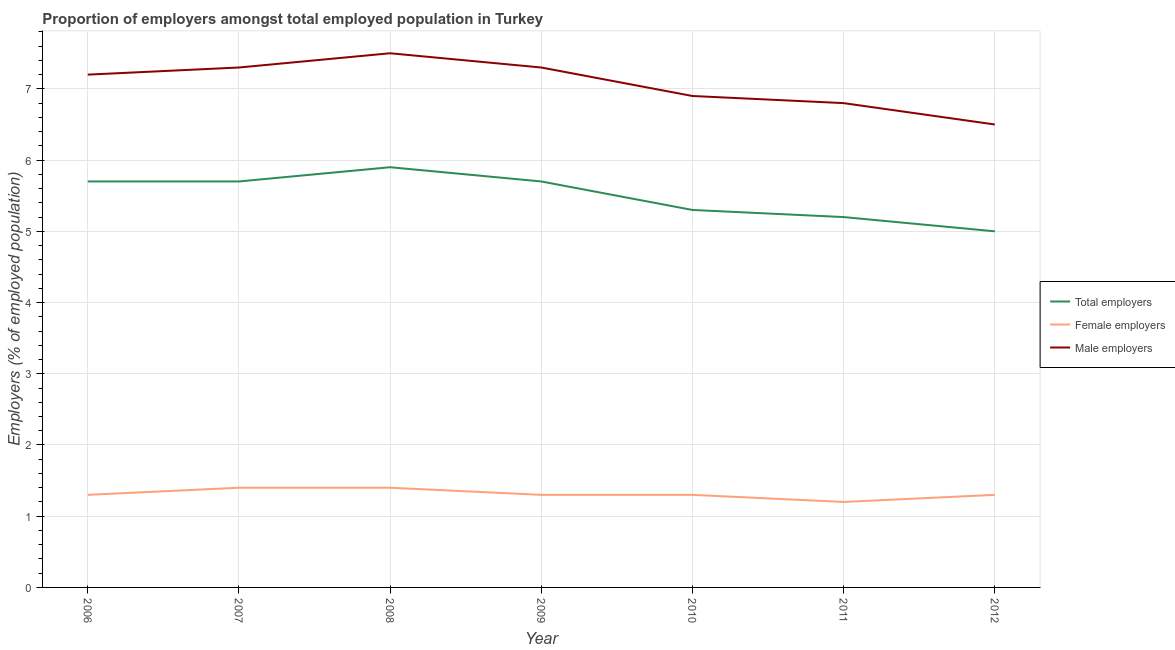What is the percentage of total employers in 2012?
Offer a very short reply. 5. Across all years, what is the maximum percentage of total employers?
Offer a very short reply. 5.9. In which year was the percentage of male employers maximum?
Your answer should be compact. 2008. What is the total percentage of female employers in the graph?
Keep it short and to the point. 9.2. What is the difference between the percentage of total employers in 2008 and that in 2012?
Provide a succinct answer. 0.9. What is the difference between the percentage of male employers in 2007 and the percentage of female employers in 2008?
Provide a succinct answer. 5.9. What is the average percentage of female employers per year?
Provide a short and direct response. 1.31. What is the ratio of the percentage of female employers in 2008 to that in 2010?
Offer a very short reply. 1.08. Is the percentage of female employers in 2007 less than that in 2010?
Offer a terse response. No. Is the difference between the percentage of total employers in 2008 and 2011 greater than the difference between the percentage of female employers in 2008 and 2011?
Give a very brief answer. Yes. What is the difference between the highest and the second highest percentage of total employers?
Offer a very short reply. 0.2. Is the percentage of total employers strictly greater than the percentage of male employers over the years?
Your response must be concise. No. Is the percentage of female employers strictly less than the percentage of male employers over the years?
Offer a terse response. Yes. How many lines are there?
Provide a succinct answer. 3. What is the difference between two consecutive major ticks on the Y-axis?
Give a very brief answer. 1. Are the values on the major ticks of Y-axis written in scientific E-notation?
Offer a terse response. No. Where does the legend appear in the graph?
Give a very brief answer. Center right. How many legend labels are there?
Give a very brief answer. 3. How are the legend labels stacked?
Offer a terse response. Vertical. What is the title of the graph?
Provide a short and direct response. Proportion of employers amongst total employed population in Turkey. What is the label or title of the Y-axis?
Ensure brevity in your answer.  Employers (% of employed population). What is the Employers (% of employed population) in Total employers in 2006?
Offer a terse response. 5.7. What is the Employers (% of employed population) of Female employers in 2006?
Keep it short and to the point. 1.3. What is the Employers (% of employed population) in Male employers in 2006?
Give a very brief answer. 7.2. What is the Employers (% of employed population) in Total employers in 2007?
Offer a very short reply. 5.7. What is the Employers (% of employed population) in Female employers in 2007?
Your answer should be compact. 1.4. What is the Employers (% of employed population) in Male employers in 2007?
Offer a terse response. 7.3. What is the Employers (% of employed population) in Total employers in 2008?
Your response must be concise. 5.9. What is the Employers (% of employed population) of Female employers in 2008?
Your response must be concise. 1.4. What is the Employers (% of employed population) of Male employers in 2008?
Offer a very short reply. 7.5. What is the Employers (% of employed population) in Total employers in 2009?
Provide a succinct answer. 5.7. What is the Employers (% of employed population) in Female employers in 2009?
Keep it short and to the point. 1.3. What is the Employers (% of employed population) in Male employers in 2009?
Your answer should be very brief. 7.3. What is the Employers (% of employed population) in Total employers in 2010?
Your answer should be compact. 5.3. What is the Employers (% of employed population) in Female employers in 2010?
Make the answer very short. 1.3. What is the Employers (% of employed population) of Male employers in 2010?
Make the answer very short. 6.9. What is the Employers (% of employed population) in Total employers in 2011?
Offer a terse response. 5.2. What is the Employers (% of employed population) of Female employers in 2011?
Offer a terse response. 1.2. What is the Employers (% of employed population) of Male employers in 2011?
Provide a succinct answer. 6.8. What is the Employers (% of employed population) in Female employers in 2012?
Your answer should be compact. 1.3. Across all years, what is the maximum Employers (% of employed population) of Total employers?
Make the answer very short. 5.9. Across all years, what is the maximum Employers (% of employed population) in Female employers?
Provide a succinct answer. 1.4. Across all years, what is the minimum Employers (% of employed population) of Female employers?
Provide a succinct answer. 1.2. Across all years, what is the minimum Employers (% of employed population) of Male employers?
Offer a very short reply. 6.5. What is the total Employers (% of employed population) in Total employers in the graph?
Your response must be concise. 38.5. What is the total Employers (% of employed population) of Male employers in the graph?
Provide a succinct answer. 49.5. What is the difference between the Employers (% of employed population) of Female employers in 2006 and that in 2007?
Ensure brevity in your answer.  -0.1. What is the difference between the Employers (% of employed population) of Male employers in 2006 and that in 2007?
Keep it short and to the point. -0.1. What is the difference between the Employers (% of employed population) in Total employers in 2006 and that in 2008?
Your answer should be compact. -0.2. What is the difference between the Employers (% of employed population) in Female employers in 2006 and that in 2008?
Your answer should be very brief. -0.1. What is the difference between the Employers (% of employed population) of Male employers in 2006 and that in 2008?
Keep it short and to the point. -0.3. What is the difference between the Employers (% of employed population) in Total employers in 2006 and that in 2009?
Ensure brevity in your answer.  0. What is the difference between the Employers (% of employed population) of Female employers in 2006 and that in 2009?
Provide a succinct answer. 0. What is the difference between the Employers (% of employed population) in Total employers in 2006 and that in 2010?
Keep it short and to the point. 0.4. What is the difference between the Employers (% of employed population) in Female employers in 2006 and that in 2010?
Provide a succinct answer. 0. What is the difference between the Employers (% of employed population) of Male employers in 2006 and that in 2010?
Your answer should be compact. 0.3. What is the difference between the Employers (% of employed population) in Female employers in 2006 and that in 2011?
Ensure brevity in your answer.  0.1. What is the difference between the Employers (% of employed population) in Total employers in 2007 and that in 2009?
Give a very brief answer. 0. What is the difference between the Employers (% of employed population) of Male employers in 2007 and that in 2009?
Ensure brevity in your answer.  0. What is the difference between the Employers (% of employed population) of Total employers in 2007 and that in 2010?
Provide a succinct answer. 0.4. What is the difference between the Employers (% of employed population) in Male employers in 2007 and that in 2010?
Your response must be concise. 0.4. What is the difference between the Employers (% of employed population) of Total employers in 2007 and that in 2011?
Your response must be concise. 0.5. What is the difference between the Employers (% of employed population) in Total employers in 2007 and that in 2012?
Ensure brevity in your answer.  0.7. What is the difference between the Employers (% of employed population) in Female employers in 2008 and that in 2009?
Make the answer very short. 0.1. What is the difference between the Employers (% of employed population) in Male employers in 2008 and that in 2009?
Offer a terse response. 0.2. What is the difference between the Employers (% of employed population) of Total employers in 2008 and that in 2010?
Your response must be concise. 0.6. What is the difference between the Employers (% of employed population) in Female employers in 2008 and that in 2010?
Keep it short and to the point. 0.1. What is the difference between the Employers (% of employed population) of Total employers in 2008 and that in 2011?
Your response must be concise. 0.7. What is the difference between the Employers (% of employed population) of Total employers in 2008 and that in 2012?
Ensure brevity in your answer.  0.9. What is the difference between the Employers (% of employed population) in Male employers in 2008 and that in 2012?
Make the answer very short. 1. What is the difference between the Employers (% of employed population) of Total employers in 2009 and that in 2010?
Your response must be concise. 0.4. What is the difference between the Employers (% of employed population) in Female employers in 2009 and that in 2010?
Give a very brief answer. 0. What is the difference between the Employers (% of employed population) in Male employers in 2009 and that in 2011?
Make the answer very short. 0.5. What is the difference between the Employers (% of employed population) in Total employers in 2009 and that in 2012?
Make the answer very short. 0.7. What is the difference between the Employers (% of employed population) of Female employers in 2009 and that in 2012?
Make the answer very short. 0. What is the difference between the Employers (% of employed population) of Male employers in 2010 and that in 2011?
Your response must be concise. 0.1. What is the difference between the Employers (% of employed population) in Male employers in 2010 and that in 2012?
Offer a very short reply. 0.4. What is the difference between the Employers (% of employed population) in Total employers in 2011 and that in 2012?
Make the answer very short. 0.2. What is the difference between the Employers (% of employed population) of Female employers in 2011 and that in 2012?
Ensure brevity in your answer.  -0.1. What is the difference between the Employers (% of employed population) of Male employers in 2011 and that in 2012?
Give a very brief answer. 0.3. What is the difference between the Employers (% of employed population) in Total employers in 2006 and the Employers (% of employed population) in Male employers in 2007?
Your answer should be compact. -1.6. What is the difference between the Employers (% of employed population) of Female employers in 2006 and the Employers (% of employed population) of Male employers in 2007?
Offer a very short reply. -6. What is the difference between the Employers (% of employed population) in Female employers in 2006 and the Employers (% of employed population) in Male employers in 2009?
Provide a short and direct response. -6. What is the difference between the Employers (% of employed population) of Female employers in 2006 and the Employers (% of employed population) of Male employers in 2011?
Offer a terse response. -5.5. What is the difference between the Employers (% of employed population) in Total employers in 2006 and the Employers (% of employed population) in Female employers in 2012?
Offer a terse response. 4.4. What is the difference between the Employers (% of employed population) in Female employers in 2006 and the Employers (% of employed population) in Male employers in 2012?
Provide a short and direct response. -5.2. What is the difference between the Employers (% of employed population) of Total employers in 2007 and the Employers (% of employed population) of Female employers in 2008?
Give a very brief answer. 4.3. What is the difference between the Employers (% of employed population) of Total employers in 2007 and the Employers (% of employed population) of Male employers in 2008?
Ensure brevity in your answer.  -1.8. What is the difference between the Employers (% of employed population) of Total employers in 2007 and the Employers (% of employed population) of Male employers in 2009?
Make the answer very short. -1.6. What is the difference between the Employers (% of employed population) of Total employers in 2007 and the Employers (% of employed population) of Female employers in 2010?
Ensure brevity in your answer.  4.4. What is the difference between the Employers (% of employed population) of Female employers in 2007 and the Employers (% of employed population) of Male employers in 2010?
Offer a terse response. -5.5. What is the difference between the Employers (% of employed population) in Total employers in 2007 and the Employers (% of employed population) in Female employers in 2011?
Offer a terse response. 4.5. What is the difference between the Employers (% of employed population) of Total employers in 2007 and the Employers (% of employed population) of Male employers in 2011?
Offer a terse response. -1.1. What is the difference between the Employers (% of employed population) of Female employers in 2007 and the Employers (% of employed population) of Male employers in 2011?
Your answer should be very brief. -5.4. What is the difference between the Employers (% of employed population) of Total employers in 2007 and the Employers (% of employed population) of Male employers in 2012?
Ensure brevity in your answer.  -0.8. What is the difference between the Employers (% of employed population) of Female employers in 2007 and the Employers (% of employed population) of Male employers in 2012?
Your answer should be very brief. -5.1. What is the difference between the Employers (% of employed population) of Total employers in 2008 and the Employers (% of employed population) of Female employers in 2009?
Give a very brief answer. 4.6. What is the difference between the Employers (% of employed population) in Total employers in 2008 and the Employers (% of employed population) in Female employers in 2010?
Make the answer very short. 4.6. What is the difference between the Employers (% of employed population) in Female employers in 2008 and the Employers (% of employed population) in Male employers in 2010?
Give a very brief answer. -5.5. What is the difference between the Employers (% of employed population) in Total employers in 2008 and the Employers (% of employed population) in Female employers in 2011?
Your response must be concise. 4.7. What is the difference between the Employers (% of employed population) of Total employers in 2008 and the Employers (% of employed population) of Female employers in 2012?
Offer a terse response. 4.6. What is the difference between the Employers (% of employed population) of Total employers in 2009 and the Employers (% of employed population) of Male employers in 2010?
Ensure brevity in your answer.  -1.2. What is the difference between the Employers (% of employed population) of Total employers in 2009 and the Employers (% of employed population) of Male employers in 2011?
Provide a short and direct response. -1.1. What is the difference between the Employers (% of employed population) of Female employers in 2009 and the Employers (% of employed population) of Male employers in 2012?
Make the answer very short. -5.2. What is the difference between the Employers (% of employed population) in Total employers in 2010 and the Employers (% of employed population) in Female employers in 2011?
Offer a very short reply. 4.1. What is the difference between the Employers (% of employed population) of Total employers in 2010 and the Employers (% of employed population) of Male employers in 2011?
Offer a very short reply. -1.5. What is the difference between the Employers (% of employed population) of Female employers in 2010 and the Employers (% of employed population) of Male employers in 2011?
Keep it short and to the point. -5.5. What is the difference between the Employers (% of employed population) in Total employers in 2010 and the Employers (% of employed population) in Female employers in 2012?
Make the answer very short. 4. What is the difference between the Employers (% of employed population) of Female employers in 2010 and the Employers (% of employed population) of Male employers in 2012?
Your answer should be compact. -5.2. What is the difference between the Employers (% of employed population) of Total employers in 2011 and the Employers (% of employed population) of Male employers in 2012?
Your answer should be compact. -1.3. What is the difference between the Employers (% of employed population) of Female employers in 2011 and the Employers (% of employed population) of Male employers in 2012?
Offer a terse response. -5.3. What is the average Employers (% of employed population) in Female employers per year?
Give a very brief answer. 1.31. What is the average Employers (% of employed population) in Male employers per year?
Make the answer very short. 7.07. In the year 2006, what is the difference between the Employers (% of employed population) in Total employers and Employers (% of employed population) in Female employers?
Your answer should be very brief. 4.4. In the year 2006, what is the difference between the Employers (% of employed population) of Total employers and Employers (% of employed population) of Male employers?
Ensure brevity in your answer.  -1.5. In the year 2007, what is the difference between the Employers (% of employed population) of Female employers and Employers (% of employed population) of Male employers?
Provide a succinct answer. -5.9. In the year 2008, what is the difference between the Employers (% of employed population) of Total employers and Employers (% of employed population) of Male employers?
Provide a succinct answer. -1.6. In the year 2009, what is the difference between the Employers (% of employed population) in Total employers and Employers (% of employed population) in Female employers?
Make the answer very short. 4.4. In the year 2009, what is the difference between the Employers (% of employed population) in Female employers and Employers (% of employed population) in Male employers?
Your answer should be very brief. -6. In the year 2010, what is the difference between the Employers (% of employed population) of Total employers and Employers (% of employed population) of Male employers?
Give a very brief answer. -1.6. In the year 2010, what is the difference between the Employers (% of employed population) in Female employers and Employers (% of employed population) in Male employers?
Keep it short and to the point. -5.6. In the year 2011, what is the difference between the Employers (% of employed population) in Total employers and Employers (% of employed population) in Male employers?
Offer a terse response. -1.6. What is the ratio of the Employers (% of employed population) in Male employers in 2006 to that in 2007?
Your answer should be compact. 0.99. What is the ratio of the Employers (% of employed population) of Total employers in 2006 to that in 2008?
Provide a short and direct response. 0.97. What is the ratio of the Employers (% of employed population) of Total employers in 2006 to that in 2009?
Provide a succinct answer. 1. What is the ratio of the Employers (% of employed population) of Female employers in 2006 to that in 2009?
Provide a succinct answer. 1. What is the ratio of the Employers (% of employed population) of Male employers in 2006 to that in 2009?
Provide a succinct answer. 0.99. What is the ratio of the Employers (% of employed population) in Total employers in 2006 to that in 2010?
Your response must be concise. 1.08. What is the ratio of the Employers (% of employed population) of Male employers in 2006 to that in 2010?
Provide a short and direct response. 1.04. What is the ratio of the Employers (% of employed population) of Total employers in 2006 to that in 2011?
Offer a very short reply. 1.1. What is the ratio of the Employers (% of employed population) of Male employers in 2006 to that in 2011?
Your answer should be very brief. 1.06. What is the ratio of the Employers (% of employed population) of Total employers in 2006 to that in 2012?
Offer a very short reply. 1.14. What is the ratio of the Employers (% of employed population) in Female employers in 2006 to that in 2012?
Your answer should be compact. 1. What is the ratio of the Employers (% of employed population) of Male employers in 2006 to that in 2012?
Provide a succinct answer. 1.11. What is the ratio of the Employers (% of employed population) in Total employers in 2007 to that in 2008?
Give a very brief answer. 0.97. What is the ratio of the Employers (% of employed population) of Female employers in 2007 to that in 2008?
Offer a very short reply. 1. What is the ratio of the Employers (% of employed population) in Male employers in 2007 to that in 2008?
Ensure brevity in your answer.  0.97. What is the ratio of the Employers (% of employed population) in Female employers in 2007 to that in 2009?
Provide a succinct answer. 1.08. What is the ratio of the Employers (% of employed population) in Total employers in 2007 to that in 2010?
Make the answer very short. 1.08. What is the ratio of the Employers (% of employed population) in Male employers in 2007 to that in 2010?
Provide a short and direct response. 1.06. What is the ratio of the Employers (% of employed population) in Total employers in 2007 to that in 2011?
Make the answer very short. 1.1. What is the ratio of the Employers (% of employed population) in Female employers in 2007 to that in 2011?
Your answer should be compact. 1.17. What is the ratio of the Employers (% of employed population) in Male employers in 2007 to that in 2011?
Provide a short and direct response. 1.07. What is the ratio of the Employers (% of employed population) in Total employers in 2007 to that in 2012?
Offer a very short reply. 1.14. What is the ratio of the Employers (% of employed population) of Male employers in 2007 to that in 2012?
Your answer should be compact. 1.12. What is the ratio of the Employers (% of employed population) of Total employers in 2008 to that in 2009?
Provide a short and direct response. 1.04. What is the ratio of the Employers (% of employed population) in Male employers in 2008 to that in 2009?
Your answer should be compact. 1.03. What is the ratio of the Employers (% of employed population) of Total employers in 2008 to that in 2010?
Offer a very short reply. 1.11. What is the ratio of the Employers (% of employed population) in Male employers in 2008 to that in 2010?
Keep it short and to the point. 1.09. What is the ratio of the Employers (% of employed population) in Total employers in 2008 to that in 2011?
Keep it short and to the point. 1.13. What is the ratio of the Employers (% of employed population) in Male employers in 2008 to that in 2011?
Give a very brief answer. 1.1. What is the ratio of the Employers (% of employed population) of Total employers in 2008 to that in 2012?
Keep it short and to the point. 1.18. What is the ratio of the Employers (% of employed population) in Male employers in 2008 to that in 2012?
Your answer should be very brief. 1.15. What is the ratio of the Employers (% of employed population) of Total employers in 2009 to that in 2010?
Give a very brief answer. 1.08. What is the ratio of the Employers (% of employed population) of Female employers in 2009 to that in 2010?
Your response must be concise. 1. What is the ratio of the Employers (% of employed population) of Male employers in 2009 to that in 2010?
Offer a terse response. 1.06. What is the ratio of the Employers (% of employed population) in Total employers in 2009 to that in 2011?
Offer a very short reply. 1.1. What is the ratio of the Employers (% of employed population) in Male employers in 2009 to that in 2011?
Your answer should be very brief. 1.07. What is the ratio of the Employers (% of employed population) of Total employers in 2009 to that in 2012?
Your answer should be compact. 1.14. What is the ratio of the Employers (% of employed population) of Female employers in 2009 to that in 2012?
Offer a very short reply. 1. What is the ratio of the Employers (% of employed population) in Male employers in 2009 to that in 2012?
Make the answer very short. 1.12. What is the ratio of the Employers (% of employed population) in Total employers in 2010 to that in 2011?
Your answer should be compact. 1.02. What is the ratio of the Employers (% of employed population) of Female employers in 2010 to that in 2011?
Your response must be concise. 1.08. What is the ratio of the Employers (% of employed population) of Male employers in 2010 to that in 2011?
Make the answer very short. 1.01. What is the ratio of the Employers (% of employed population) in Total employers in 2010 to that in 2012?
Your answer should be compact. 1.06. What is the ratio of the Employers (% of employed population) in Male employers in 2010 to that in 2012?
Your answer should be very brief. 1.06. What is the ratio of the Employers (% of employed population) in Female employers in 2011 to that in 2012?
Your answer should be very brief. 0.92. What is the ratio of the Employers (% of employed population) of Male employers in 2011 to that in 2012?
Your answer should be compact. 1.05. What is the difference between the highest and the lowest Employers (% of employed population) of Male employers?
Your answer should be very brief. 1. 